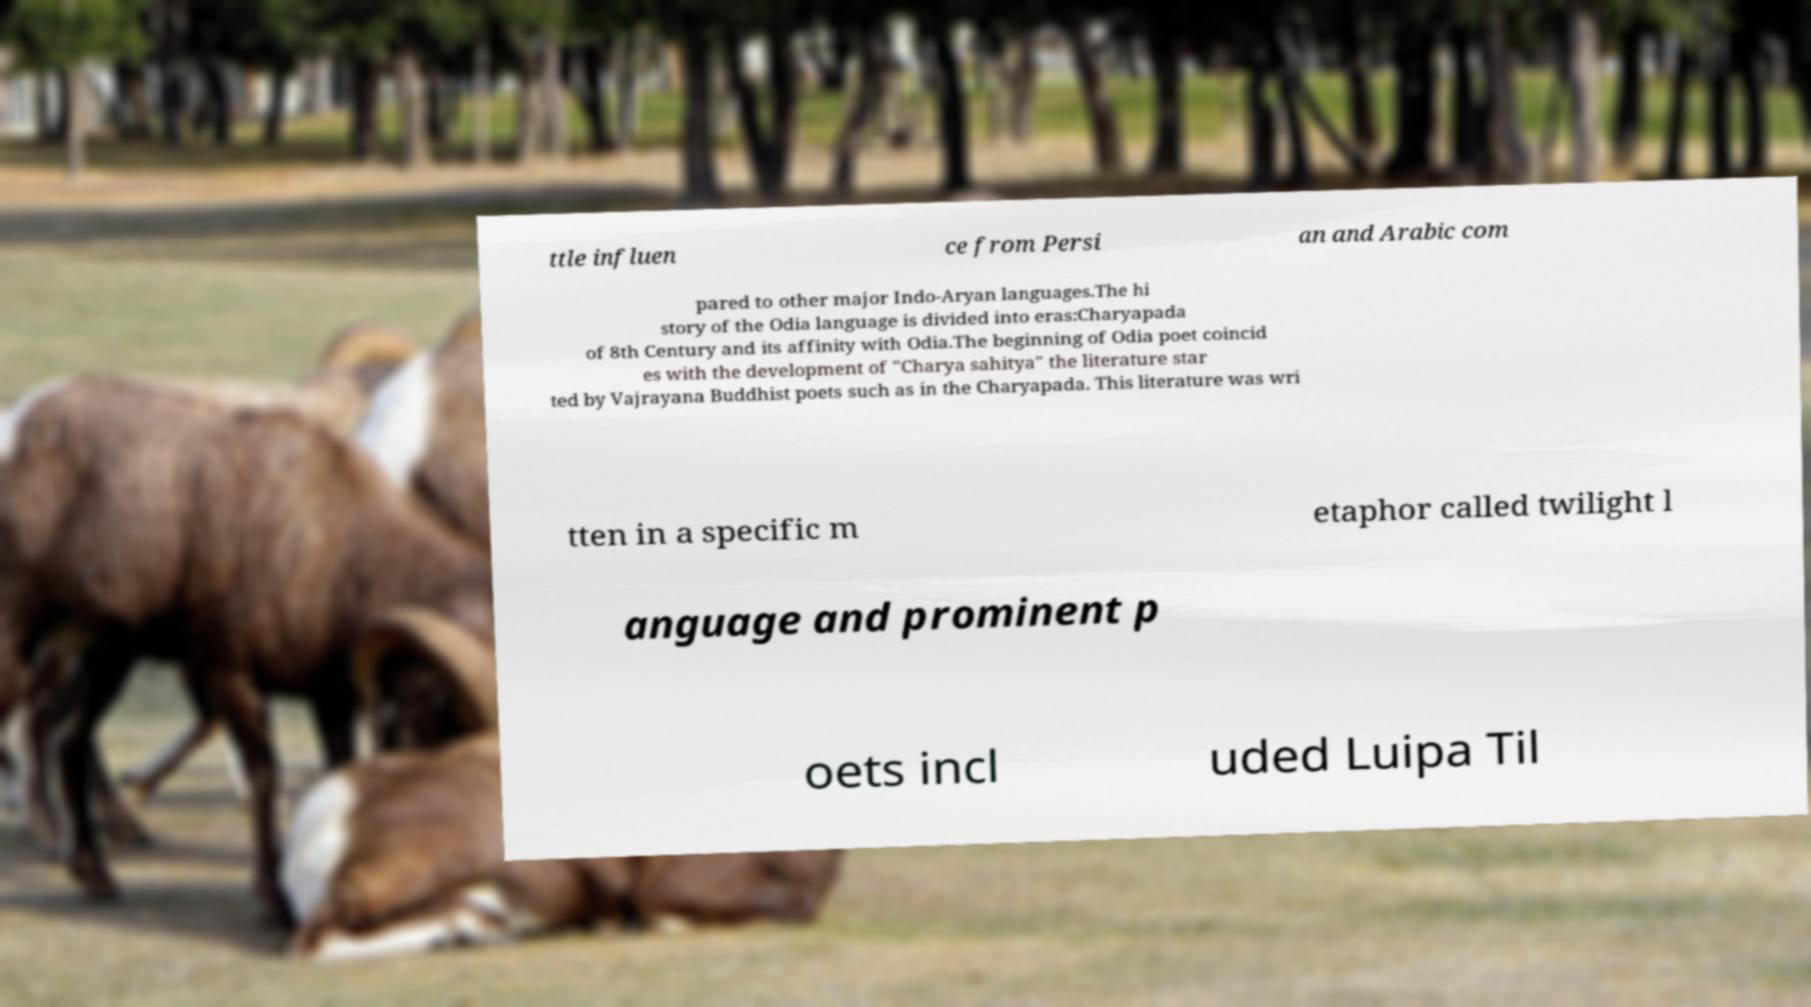For documentation purposes, I need the text within this image transcribed. Could you provide that? ttle influen ce from Persi an and Arabic com pared to other major Indo-Aryan languages.The hi story of the Odia language is divided into eras:Charyapada of 8th Century and its affinity with Odia.The beginning of Odia poet coincid es with the development of "Charya sahitya" the literature star ted by Vajrayana Buddhist poets such as in the Charyapada. This literature was wri tten in a specific m etaphor called twilight l anguage and prominent p oets incl uded Luipa Til 